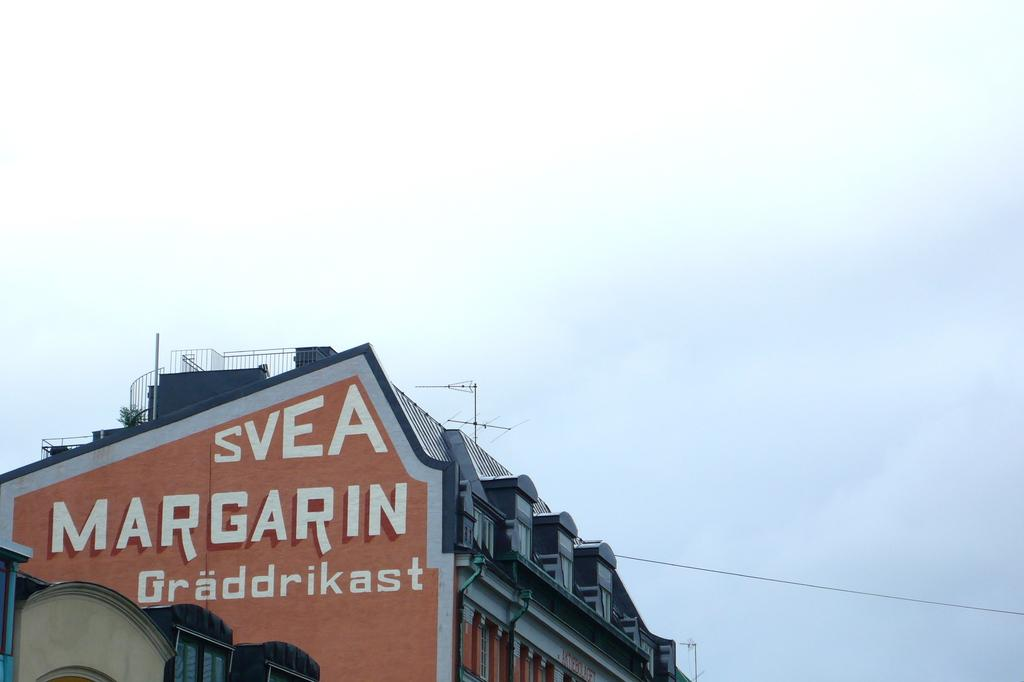What type of structure is visible in the image? There is a building in the image. What is the condition of the sky in the image? The sky is covered with clouds. What type of oatmeal is being served in the image? There is no oatmeal present in the image. Can you solve the riddle that is depicted in the image? There is no riddle depicted in the image. 